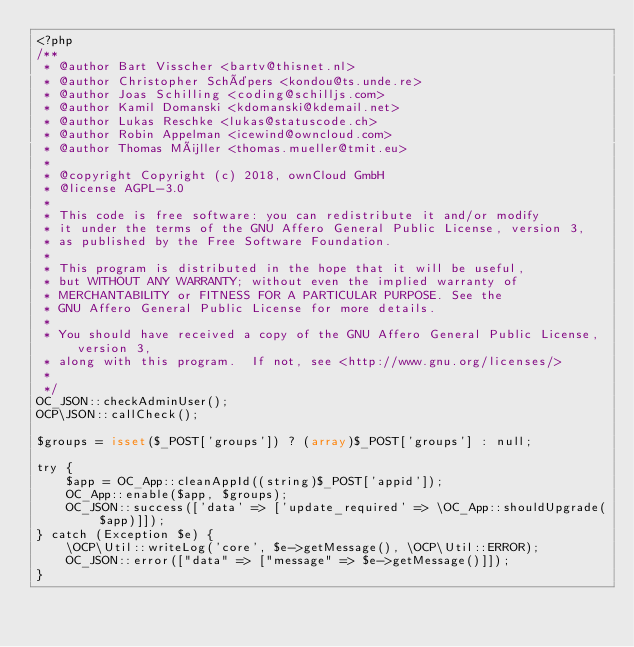<code> <loc_0><loc_0><loc_500><loc_500><_PHP_><?php
/**
 * @author Bart Visscher <bartv@thisnet.nl>
 * @author Christopher Schäpers <kondou@ts.unde.re>
 * @author Joas Schilling <coding@schilljs.com>
 * @author Kamil Domanski <kdomanski@kdemail.net>
 * @author Lukas Reschke <lukas@statuscode.ch>
 * @author Robin Appelman <icewind@owncloud.com>
 * @author Thomas Müller <thomas.mueller@tmit.eu>
 *
 * @copyright Copyright (c) 2018, ownCloud GmbH
 * @license AGPL-3.0
 *
 * This code is free software: you can redistribute it and/or modify
 * it under the terms of the GNU Affero General Public License, version 3,
 * as published by the Free Software Foundation.
 *
 * This program is distributed in the hope that it will be useful,
 * but WITHOUT ANY WARRANTY; without even the implied warranty of
 * MERCHANTABILITY or FITNESS FOR A PARTICULAR PURPOSE. See the
 * GNU Affero General Public License for more details.
 *
 * You should have received a copy of the GNU Affero General Public License, version 3,
 * along with this program.  If not, see <http://www.gnu.org/licenses/>
 *
 */
OC_JSON::checkAdminUser();
OCP\JSON::callCheck();

$groups = isset($_POST['groups']) ? (array)$_POST['groups'] : null;

try {
	$app = OC_App::cleanAppId((string)$_POST['appid']);
	OC_App::enable($app, $groups);
	OC_JSON::success(['data' => ['update_required' => \OC_App::shouldUpgrade($app)]]);
} catch (Exception $e) {
	\OCP\Util::writeLog('core', $e->getMessage(), \OCP\Util::ERROR);
	OC_JSON::error(["data" => ["message" => $e->getMessage()]]);
}
</code> 